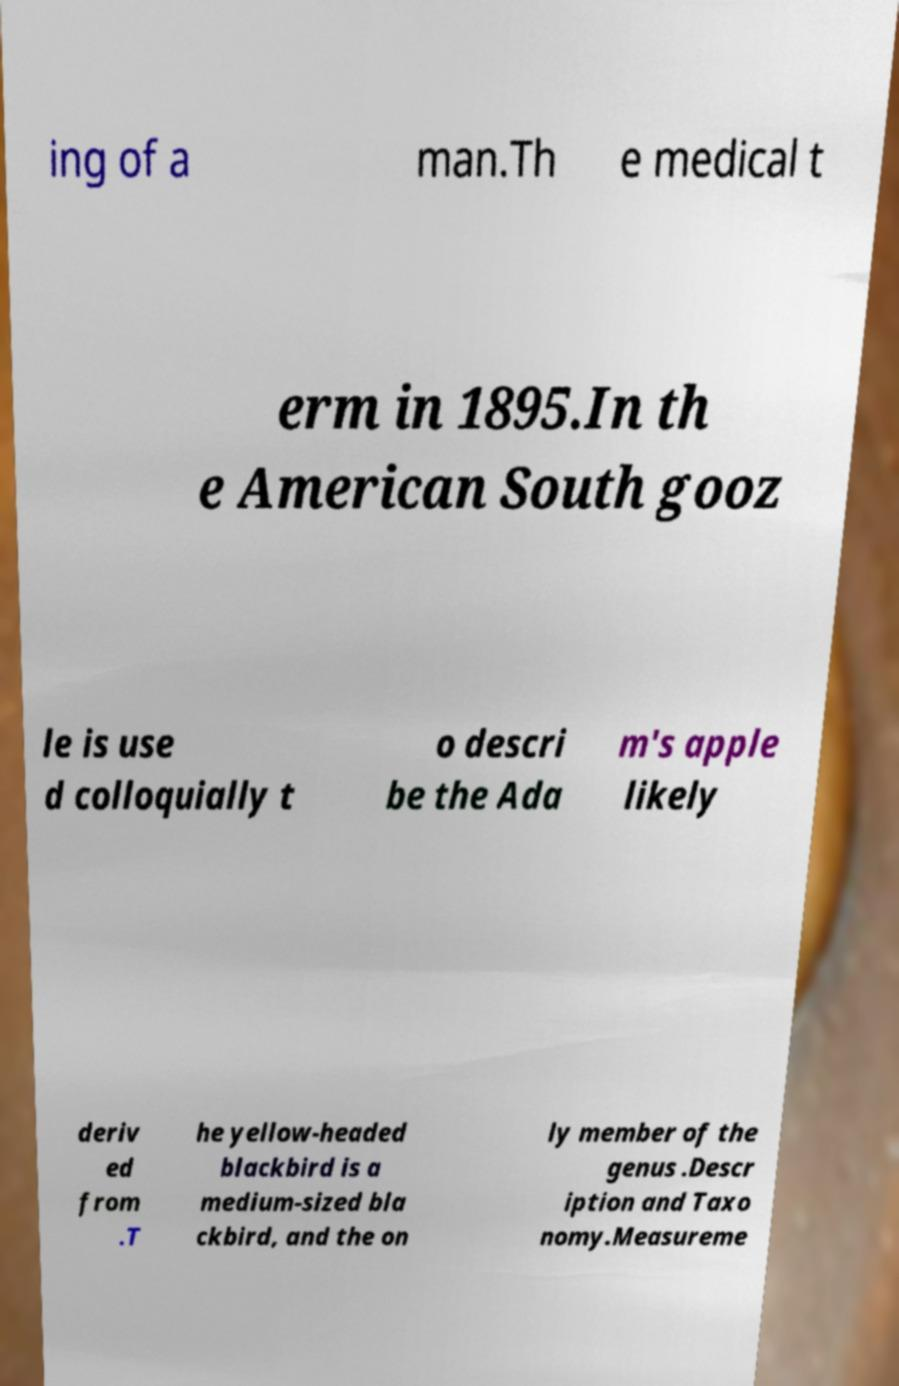Can you read and provide the text displayed in the image?This photo seems to have some interesting text. Can you extract and type it out for me? ing of a man.Th e medical t erm in 1895.In th e American South gooz le is use d colloquially t o descri be the Ada m's apple likely deriv ed from .T he yellow-headed blackbird is a medium-sized bla ckbird, and the on ly member of the genus .Descr iption and Taxo nomy.Measureme 